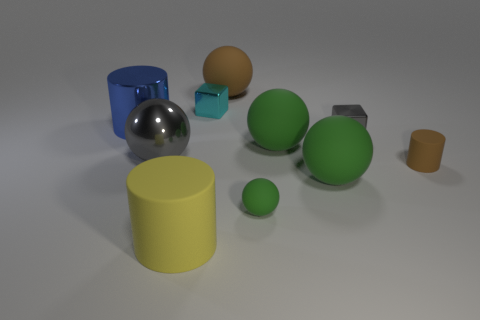Subtract all yellow cylinders. How many green spheres are left? 3 Subtract all small green matte balls. How many balls are left? 4 Subtract all gray balls. How many balls are left? 4 Subtract all cylinders. How many objects are left? 7 Subtract all brown balls. Subtract all cyan cylinders. How many balls are left? 4 Subtract all brown matte cylinders. Subtract all large blue objects. How many objects are left? 8 Add 3 small green objects. How many small green objects are left? 4 Add 9 small gray things. How many small gray things exist? 10 Subtract 0 brown cubes. How many objects are left? 10 